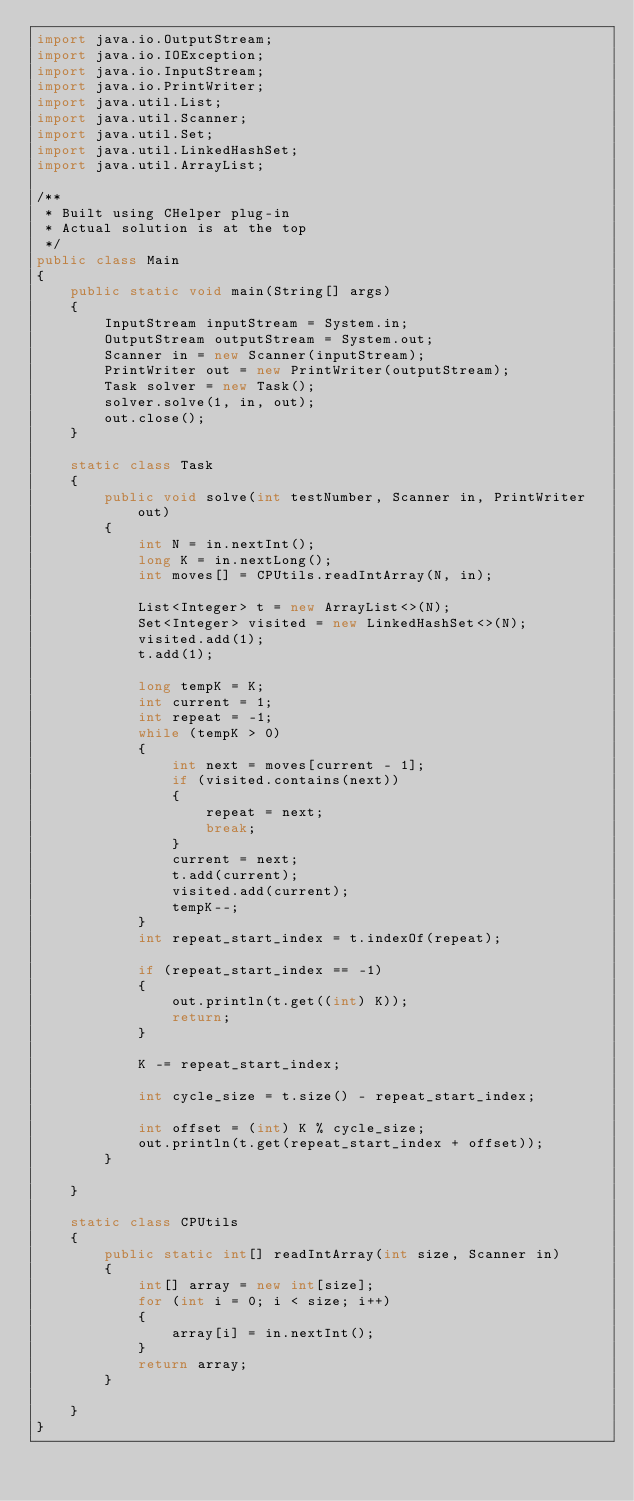Convert code to text. <code><loc_0><loc_0><loc_500><loc_500><_Java_>import java.io.OutputStream;
import java.io.IOException;
import java.io.InputStream;
import java.io.PrintWriter;
import java.util.List;
import java.util.Scanner;
import java.util.Set;
import java.util.LinkedHashSet;
import java.util.ArrayList;

/**
 * Built using CHelper plug-in
 * Actual solution is at the top
 */
public class Main
{
    public static void main(String[] args)
    {
        InputStream inputStream = System.in;
        OutputStream outputStream = System.out;
        Scanner in = new Scanner(inputStream);
        PrintWriter out = new PrintWriter(outputStream);
        Task solver = new Task();
        solver.solve(1, in, out);
        out.close();
    }

    static class Task
    {
        public void solve(int testNumber, Scanner in, PrintWriter out)
        {
            int N = in.nextInt();
            long K = in.nextLong();
            int moves[] = CPUtils.readIntArray(N, in);

            List<Integer> t = new ArrayList<>(N);
            Set<Integer> visited = new LinkedHashSet<>(N);
            visited.add(1);
            t.add(1);

            long tempK = K;
            int current = 1;
            int repeat = -1;
            while (tempK > 0)
            {
                int next = moves[current - 1];
                if (visited.contains(next))
                {
                    repeat = next;
                    break;
                }
                current = next;
                t.add(current);
                visited.add(current);
                tempK--;
            }
            int repeat_start_index = t.indexOf(repeat);

            if (repeat_start_index == -1)
            {
                out.println(t.get((int) K));
                return;
            }

            K -= repeat_start_index;

            int cycle_size = t.size() - repeat_start_index;

            int offset = (int) K % cycle_size;
            out.println(t.get(repeat_start_index + offset));
        }

    }

    static class CPUtils
    {
        public static int[] readIntArray(int size, Scanner in)
        {
            int[] array = new int[size];
            for (int i = 0; i < size; i++)
            {
                array[i] = in.nextInt();
            }
            return array;
        }

    }
}

</code> 